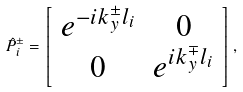<formula> <loc_0><loc_0><loc_500><loc_500>\hat { P } _ { i } ^ { \pm } = \left [ \begin{array} { c c } e ^ { - i k _ { y } ^ { \pm } l _ { i } } & 0 \\ 0 & e ^ { i k _ { y } ^ { \mp } l _ { i } } \end{array} \right ] ,</formula> 